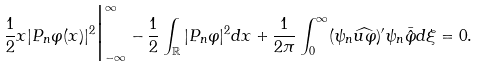<formula> <loc_0><loc_0><loc_500><loc_500>\frac { 1 } { 2 } x | P _ { n } \varphi ( x ) | ^ { 2 } \Big | _ { - \infty } ^ { \infty } - \frac { 1 } { 2 } \int _ { \mathbb { R } } | P _ { n } \varphi | ^ { 2 } d x + \frac { 1 } { 2 \pi } \int _ { 0 } ^ { \infty } ( \psi _ { n } \widehat { u \varphi } ) ^ { \prime } \psi _ { n } \bar { \hat { \varphi } } d \xi = 0 .</formula> 